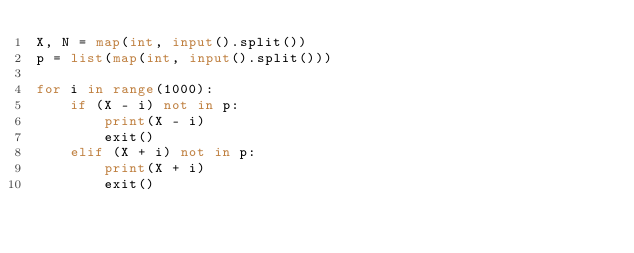<code> <loc_0><loc_0><loc_500><loc_500><_Python_>X, N = map(int, input().split())
p = list(map(int, input().split()))

for i in range(1000):
    if (X - i) not in p:
        print(X - i)
        exit()
    elif (X + i) not in p:
        print(X + i)
        exit()</code> 